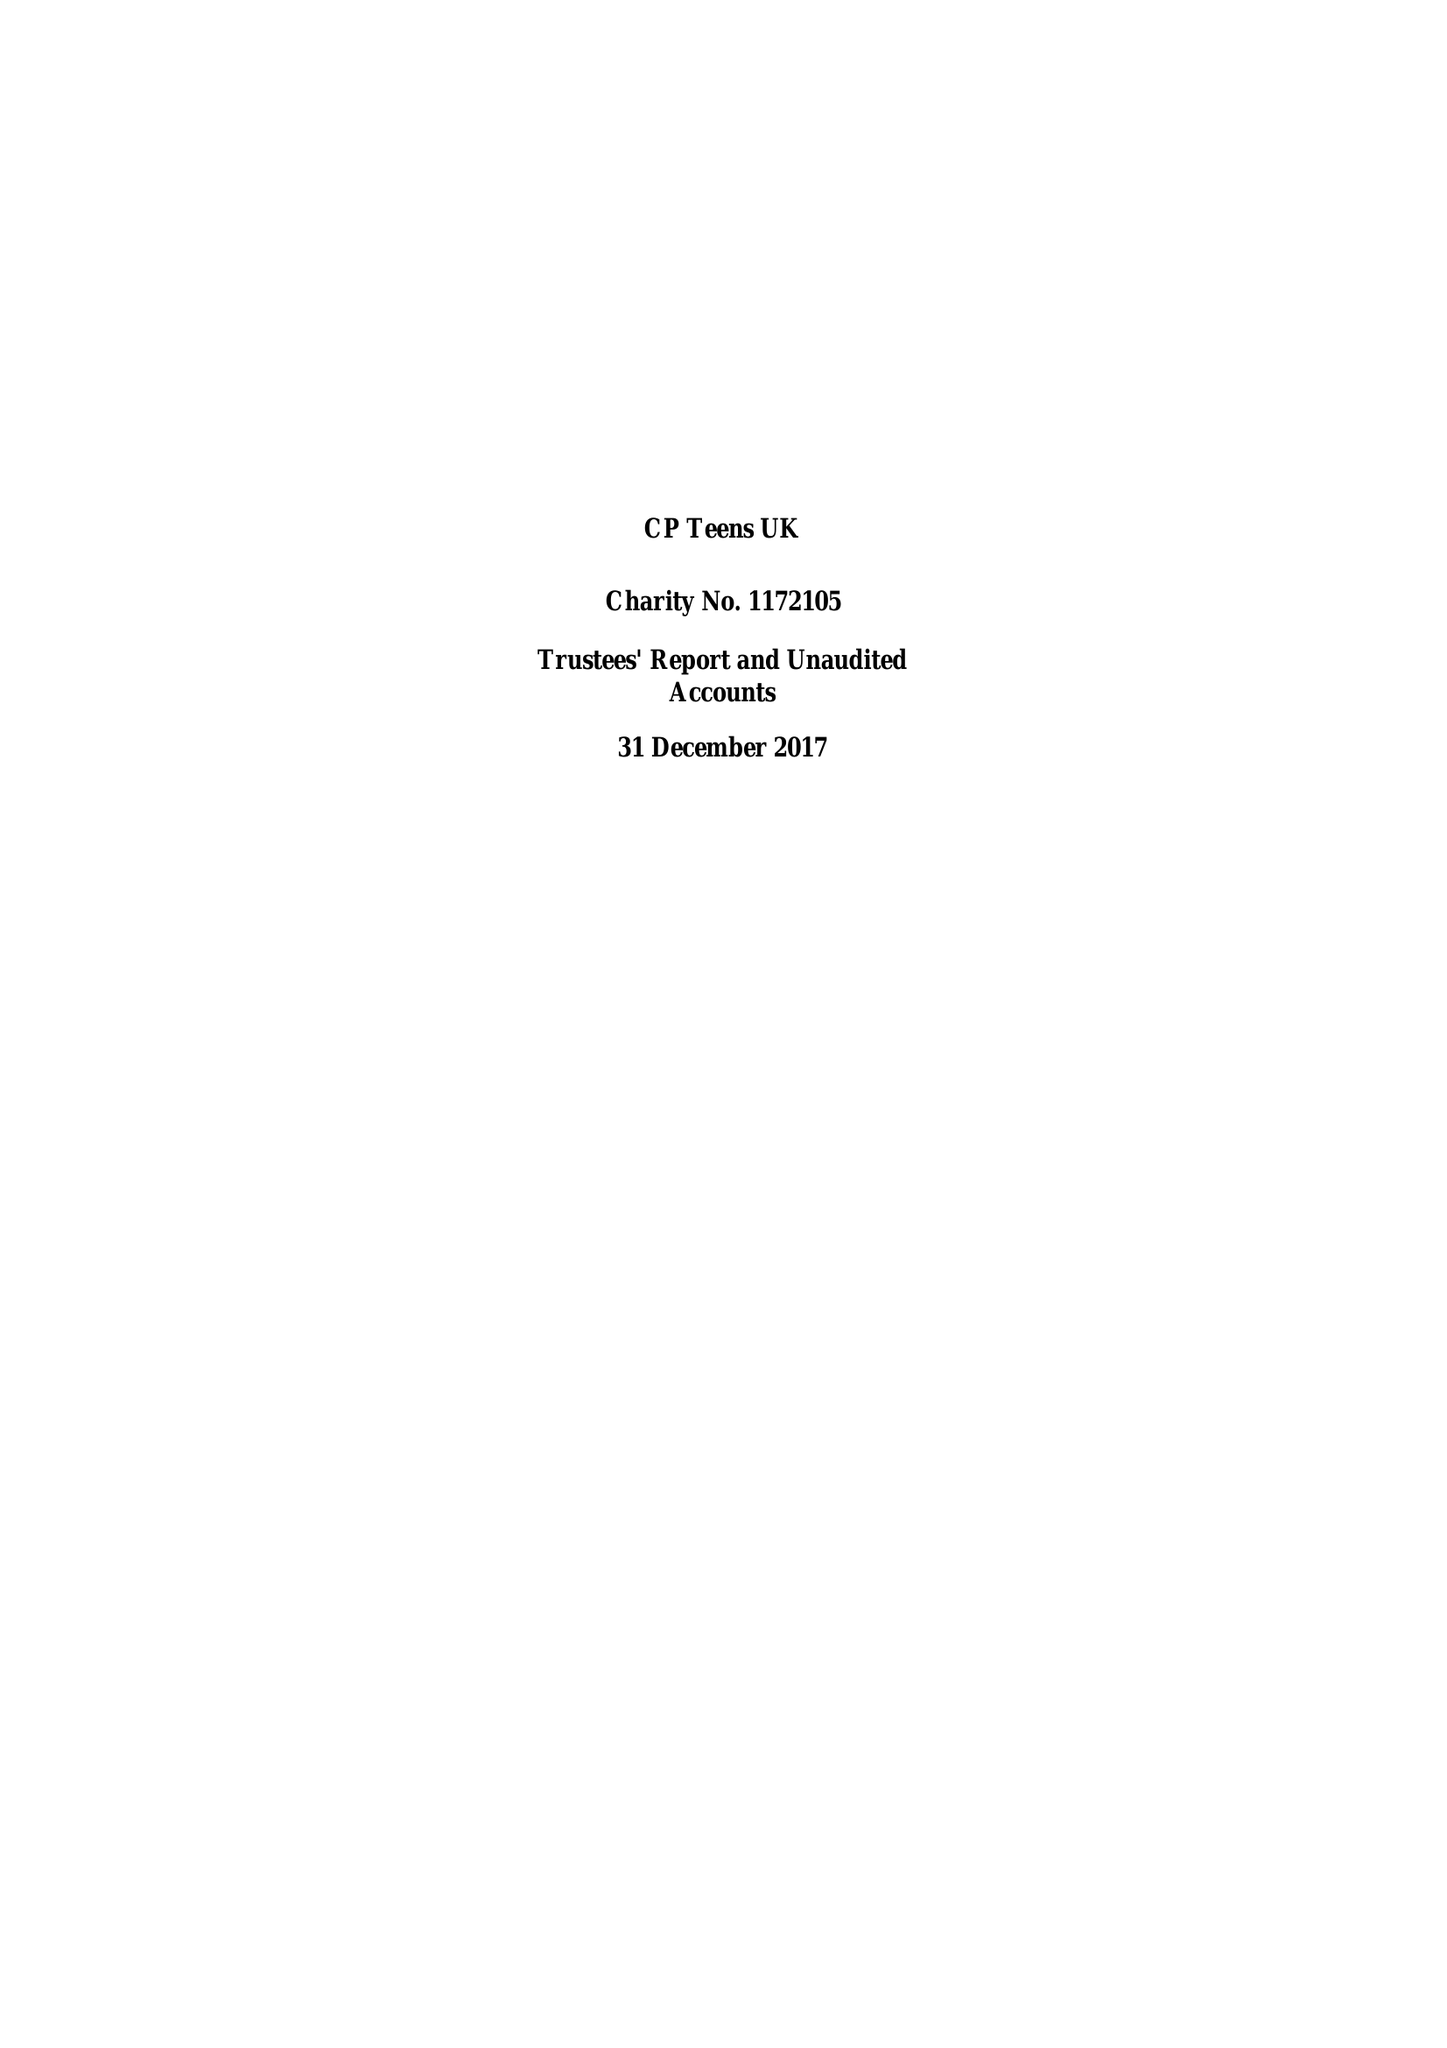What is the value for the charity_name?
Answer the question using a single word or phrase. Cp Teens Uk 